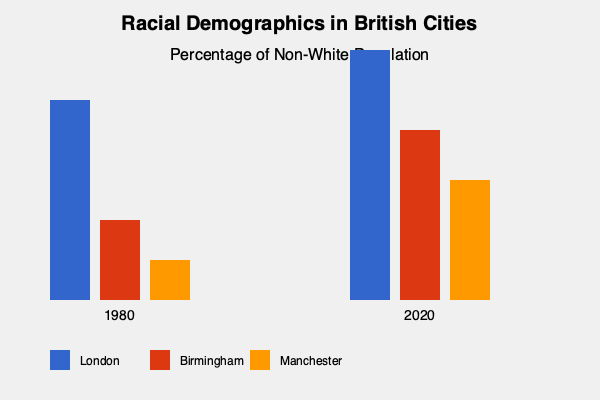Based on the graph showing racial demographics in British cities, which city experienced the most significant increase in its non-white population between 1980 and 2020? To determine which city had the most significant increase in its non-white population, we need to compare the change in bar heights for each city from 1980 to 2020:

1. London (blue bars):
   - 1980: Bar height is 200 units
   - 2020: Bar height is 250 units
   - Increase: 250 - 200 = 50 units

2. Birmingham (red bars):
   - 1980: Bar height is 80 units
   - 2020: Bar height is 170 units
   - Increase: 170 - 80 = 90 units

3. Manchester (orange bars):
   - 1980: Bar height is 40 units
   - 2020: Bar height is 120 units
   - Increase: 120 - 40 = 80 units

Comparing the increases:
- London: 50 units
- Birmingham: 90 units
- Manchester: 80 units

Birmingham shows the largest increase in bar height, representing the most significant growth in its non-white population from 1980 to 2020.
Answer: Birmingham 